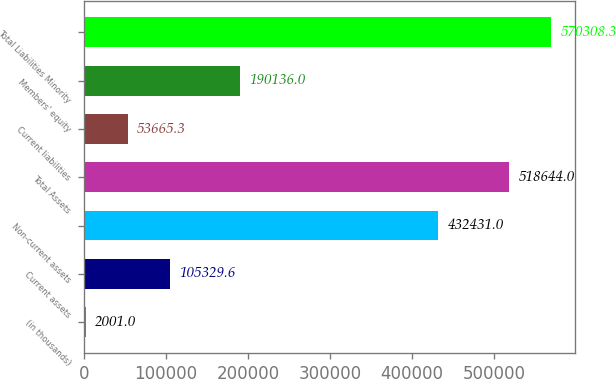Convert chart to OTSL. <chart><loc_0><loc_0><loc_500><loc_500><bar_chart><fcel>(in thousands)<fcel>Current assets<fcel>Non-current assets<fcel>Total Assets<fcel>Current liabilities<fcel>Members' equity<fcel>Total Liabilities Minority<nl><fcel>2001<fcel>105330<fcel>432431<fcel>518644<fcel>53665.3<fcel>190136<fcel>570308<nl></chart> 